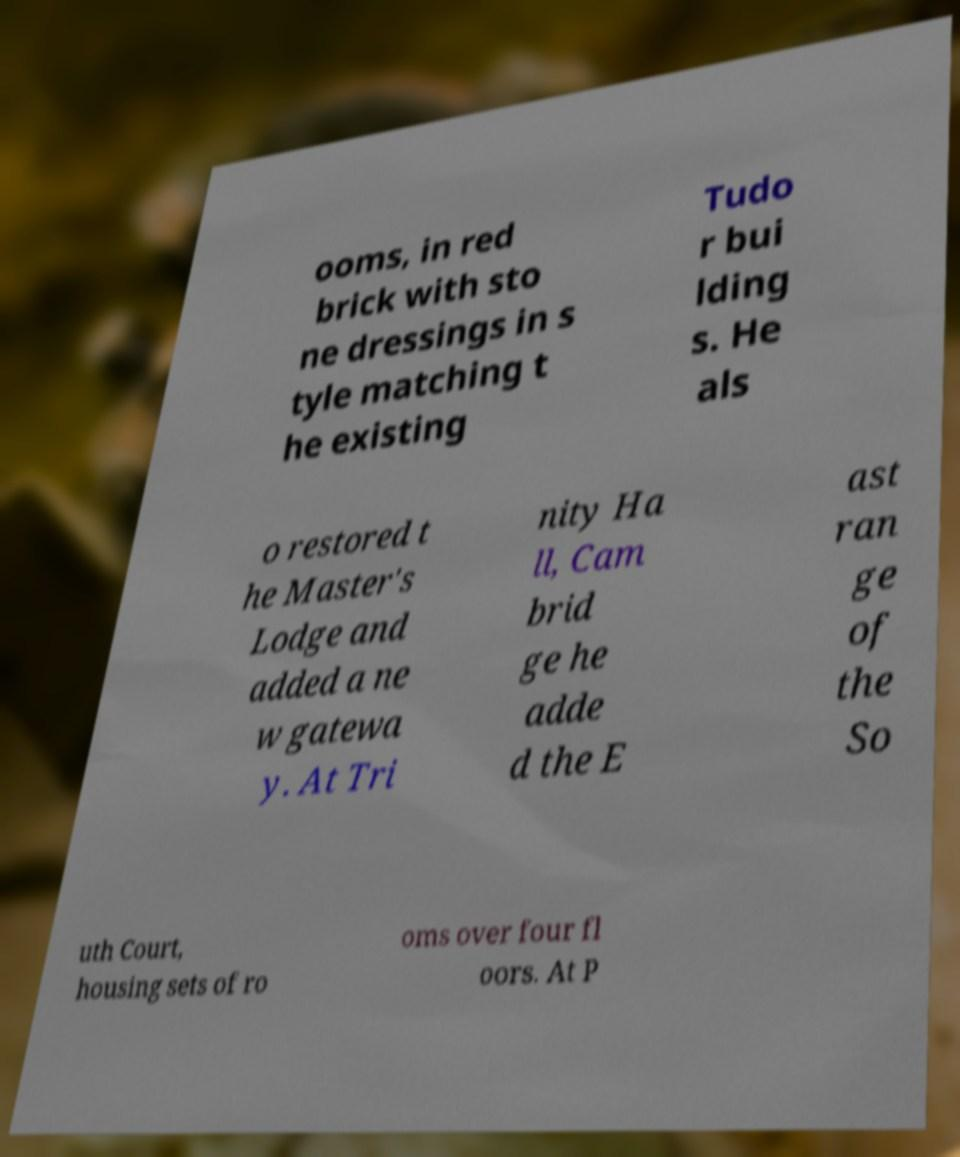What messages or text are displayed in this image? I need them in a readable, typed format. ooms, in red brick with sto ne dressings in s tyle matching t he existing Tudo r bui lding s. He als o restored t he Master's Lodge and added a ne w gatewa y. At Tri nity Ha ll, Cam brid ge he adde d the E ast ran ge of the So uth Court, housing sets of ro oms over four fl oors. At P 